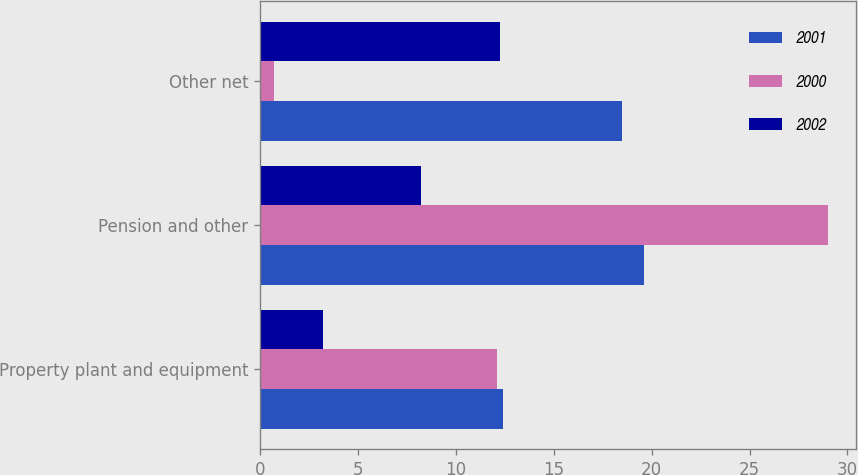<chart> <loc_0><loc_0><loc_500><loc_500><stacked_bar_chart><ecel><fcel>Property plant and equipment<fcel>Pension and other<fcel>Other net<nl><fcel>2001<fcel>12.4<fcel>19.6<fcel>18.5<nl><fcel>2000<fcel>12.1<fcel>29<fcel>0.7<nl><fcel>2002<fcel>3.2<fcel>8.2<fcel>12.25<nl></chart> 